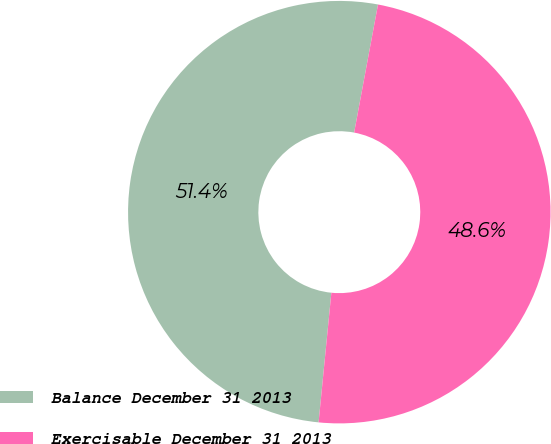<chart> <loc_0><loc_0><loc_500><loc_500><pie_chart><fcel>Balance December 31 2013<fcel>Exercisable December 31 2013<nl><fcel>51.37%<fcel>48.63%<nl></chart> 